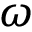Convert formula to latex. <formula><loc_0><loc_0><loc_500><loc_500>\omega</formula> 